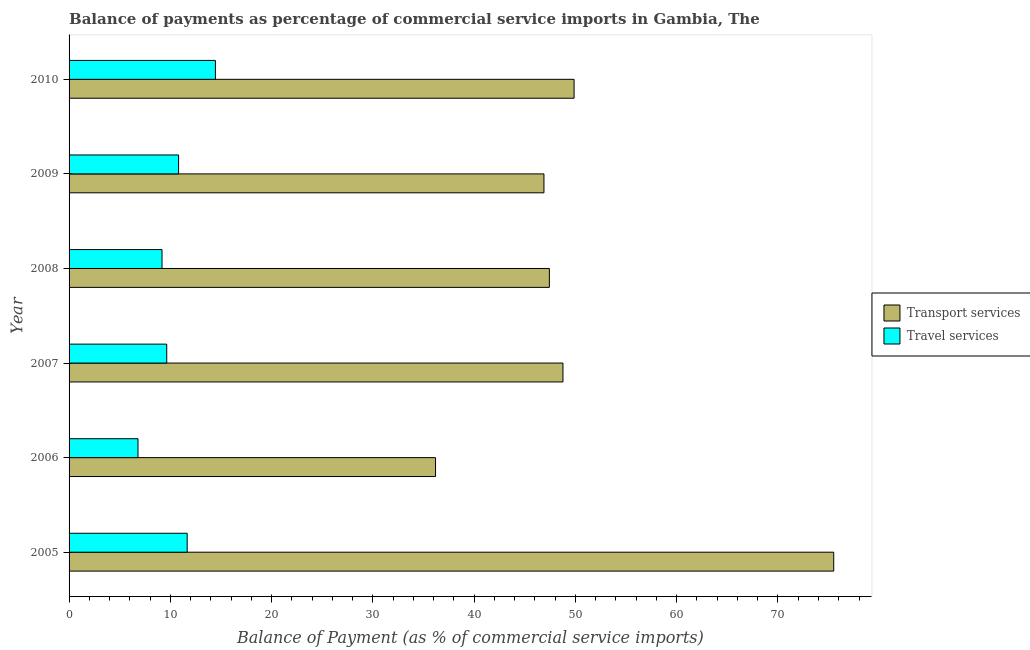How many different coloured bars are there?
Provide a short and direct response. 2. Are the number of bars on each tick of the Y-axis equal?
Keep it short and to the point. Yes. In how many cases, is the number of bars for a given year not equal to the number of legend labels?
Ensure brevity in your answer.  0. What is the balance of payments of travel services in 2005?
Offer a very short reply. 11.66. Across all years, what is the maximum balance of payments of transport services?
Your response must be concise. 75.5. Across all years, what is the minimum balance of payments of travel services?
Your response must be concise. 6.81. In which year was the balance of payments of travel services maximum?
Make the answer very short. 2010. What is the total balance of payments of travel services in the graph?
Your answer should be compact. 62.56. What is the difference between the balance of payments of transport services in 2006 and that in 2009?
Provide a succinct answer. -10.71. What is the difference between the balance of payments of travel services in 2010 and the balance of payments of transport services in 2005?
Your answer should be very brief. -61.05. What is the average balance of payments of travel services per year?
Your answer should be very brief. 10.43. In the year 2010, what is the difference between the balance of payments of transport services and balance of payments of travel services?
Offer a terse response. 35.41. In how many years, is the balance of payments of transport services greater than 54 %?
Provide a short and direct response. 1. What is the ratio of the balance of payments of transport services in 2005 to that in 2006?
Keep it short and to the point. 2.09. What is the difference between the highest and the second highest balance of payments of transport services?
Offer a very short reply. 25.64. What is the difference between the highest and the lowest balance of payments of transport services?
Your answer should be compact. 39.32. In how many years, is the balance of payments of travel services greater than the average balance of payments of travel services taken over all years?
Make the answer very short. 3. What does the 2nd bar from the top in 2008 represents?
Give a very brief answer. Transport services. What does the 1st bar from the bottom in 2007 represents?
Provide a succinct answer. Transport services. How many bars are there?
Provide a short and direct response. 12. Are all the bars in the graph horizontal?
Make the answer very short. Yes. Does the graph contain any zero values?
Your answer should be compact. No. Does the graph contain grids?
Offer a terse response. No. Where does the legend appear in the graph?
Ensure brevity in your answer.  Center right. How many legend labels are there?
Your response must be concise. 2. What is the title of the graph?
Offer a terse response. Balance of payments as percentage of commercial service imports in Gambia, The. What is the label or title of the X-axis?
Provide a short and direct response. Balance of Payment (as % of commercial service imports). What is the label or title of the Y-axis?
Offer a very short reply. Year. What is the Balance of Payment (as % of commercial service imports) in Transport services in 2005?
Your answer should be very brief. 75.5. What is the Balance of Payment (as % of commercial service imports) in Travel services in 2005?
Your response must be concise. 11.66. What is the Balance of Payment (as % of commercial service imports) in Transport services in 2006?
Offer a very short reply. 36.18. What is the Balance of Payment (as % of commercial service imports) in Travel services in 2006?
Provide a succinct answer. 6.81. What is the Balance of Payment (as % of commercial service imports) in Transport services in 2007?
Give a very brief answer. 48.77. What is the Balance of Payment (as % of commercial service imports) in Travel services in 2007?
Make the answer very short. 9.64. What is the Balance of Payment (as % of commercial service imports) of Transport services in 2008?
Your response must be concise. 47.43. What is the Balance of Payment (as % of commercial service imports) of Travel services in 2008?
Offer a terse response. 9.18. What is the Balance of Payment (as % of commercial service imports) of Transport services in 2009?
Make the answer very short. 46.89. What is the Balance of Payment (as % of commercial service imports) in Travel services in 2009?
Provide a short and direct response. 10.81. What is the Balance of Payment (as % of commercial service imports) in Transport services in 2010?
Provide a short and direct response. 49.87. What is the Balance of Payment (as % of commercial service imports) in Travel services in 2010?
Make the answer very short. 14.45. Across all years, what is the maximum Balance of Payment (as % of commercial service imports) in Transport services?
Provide a short and direct response. 75.5. Across all years, what is the maximum Balance of Payment (as % of commercial service imports) in Travel services?
Provide a short and direct response. 14.45. Across all years, what is the minimum Balance of Payment (as % of commercial service imports) of Transport services?
Give a very brief answer. 36.18. Across all years, what is the minimum Balance of Payment (as % of commercial service imports) of Travel services?
Your answer should be very brief. 6.81. What is the total Balance of Payment (as % of commercial service imports) in Transport services in the graph?
Ensure brevity in your answer.  304.64. What is the total Balance of Payment (as % of commercial service imports) of Travel services in the graph?
Keep it short and to the point. 62.55. What is the difference between the Balance of Payment (as % of commercial service imports) in Transport services in 2005 and that in 2006?
Your answer should be very brief. 39.32. What is the difference between the Balance of Payment (as % of commercial service imports) in Travel services in 2005 and that in 2006?
Provide a succinct answer. 4.86. What is the difference between the Balance of Payment (as % of commercial service imports) of Transport services in 2005 and that in 2007?
Make the answer very short. 26.74. What is the difference between the Balance of Payment (as % of commercial service imports) in Travel services in 2005 and that in 2007?
Provide a succinct answer. 2.02. What is the difference between the Balance of Payment (as % of commercial service imports) in Transport services in 2005 and that in 2008?
Ensure brevity in your answer.  28.08. What is the difference between the Balance of Payment (as % of commercial service imports) in Travel services in 2005 and that in 2008?
Provide a short and direct response. 2.49. What is the difference between the Balance of Payment (as % of commercial service imports) of Transport services in 2005 and that in 2009?
Offer a terse response. 28.61. What is the difference between the Balance of Payment (as % of commercial service imports) in Travel services in 2005 and that in 2009?
Provide a succinct answer. 0.85. What is the difference between the Balance of Payment (as % of commercial service imports) of Transport services in 2005 and that in 2010?
Your response must be concise. 25.64. What is the difference between the Balance of Payment (as % of commercial service imports) in Travel services in 2005 and that in 2010?
Give a very brief answer. -2.79. What is the difference between the Balance of Payment (as % of commercial service imports) of Transport services in 2006 and that in 2007?
Your answer should be very brief. -12.58. What is the difference between the Balance of Payment (as % of commercial service imports) in Travel services in 2006 and that in 2007?
Offer a very short reply. -2.84. What is the difference between the Balance of Payment (as % of commercial service imports) of Transport services in 2006 and that in 2008?
Your answer should be very brief. -11.24. What is the difference between the Balance of Payment (as % of commercial service imports) of Travel services in 2006 and that in 2008?
Provide a short and direct response. -2.37. What is the difference between the Balance of Payment (as % of commercial service imports) in Transport services in 2006 and that in 2009?
Provide a short and direct response. -10.71. What is the difference between the Balance of Payment (as % of commercial service imports) in Travel services in 2006 and that in 2009?
Keep it short and to the point. -4.01. What is the difference between the Balance of Payment (as % of commercial service imports) in Transport services in 2006 and that in 2010?
Give a very brief answer. -13.68. What is the difference between the Balance of Payment (as % of commercial service imports) of Travel services in 2006 and that in 2010?
Provide a short and direct response. -7.64. What is the difference between the Balance of Payment (as % of commercial service imports) in Transport services in 2007 and that in 2008?
Your response must be concise. 1.34. What is the difference between the Balance of Payment (as % of commercial service imports) in Travel services in 2007 and that in 2008?
Make the answer very short. 0.47. What is the difference between the Balance of Payment (as % of commercial service imports) of Transport services in 2007 and that in 2009?
Your answer should be very brief. 1.88. What is the difference between the Balance of Payment (as % of commercial service imports) of Travel services in 2007 and that in 2009?
Give a very brief answer. -1.17. What is the difference between the Balance of Payment (as % of commercial service imports) in Transport services in 2007 and that in 2010?
Give a very brief answer. -1.1. What is the difference between the Balance of Payment (as % of commercial service imports) in Travel services in 2007 and that in 2010?
Offer a very short reply. -4.81. What is the difference between the Balance of Payment (as % of commercial service imports) in Transport services in 2008 and that in 2009?
Your response must be concise. 0.54. What is the difference between the Balance of Payment (as % of commercial service imports) in Travel services in 2008 and that in 2009?
Your response must be concise. -1.64. What is the difference between the Balance of Payment (as % of commercial service imports) in Transport services in 2008 and that in 2010?
Offer a terse response. -2.44. What is the difference between the Balance of Payment (as % of commercial service imports) in Travel services in 2008 and that in 2010?
Your response must be concise. -5.27. What is the difference between the Balance of Payment (as % of commercial service imports) of Transport services in 2009 and that in 2010?
Your answer should be compact. -2.98. What is the difference between the Balance of Payment (as % of commercial service imports) in Travel services in 2009 and that in 2010?
Your answer should be compact. -3.64. What is the difference between the Balance of Payment (as % of commercial service imports) of Transport services in 2005 and the Balance of Payment (as % of commercial service imports) of Travel services in 2006?
Keep it short and to the point. 68.7. What is the difference between the Balance of Payment (as % of commercial service imports) of Transport services in 2005 and the Balance of Payment (as % of commercial service imports) of Travel services in 2007?
Offer a very short reply. 65.86. What is the difference between the Balance of Payment (as % of commercial service imports) in Transport services in 2005 and the Balance of Payment (as % of commercial service imports) in Travel services in 2008?
Keep it short and to the point. 66.32. What is the difference between the Balance of Payment (as % of commercial service imports) of Transport services in 2005 and the Balance of Payment (as % of commercial service imports) of Travel services in 2009?
Your response must be concise. 64.69. What is the difference between the Balance of Payment (as % of commercial service imports) of Transport services in 2005 and the Balance of Payment (as % of commercial service imports) of Travel services in 2010?
Give a very brief answer. 61.05. What is the difference between the Balance of Payment (as % of commercial service imports) of Transport services in 2006 and the Balance of Payment (as % of commercial service imports) of Travel services in 2007?
Offer a very short reply. 26.54. What is the difference between the Balance of Payment (as % of commercial service imports) in Transport services in 2006 and the Balance of Payment (as % of commercial service imports) in Travel services in 2008?
Your answer should be very brief. 27.01. What is the difference between the Balance of Payment (as % of commercial service imports) of Transport services in 2006 and the Balance of Payment (as % of commercial service imports) of Travel services in 2009?
Provide a succinct answer. 25.37. What is the difference between the Balance of Payment (as % of commercial service imports) of Transport services in 2006 and the Balance of Payment (as % of commercial service imports) of Travel services in 2010?
Your response must be concise. 21.73. What is the difference between the Balance of Payment (as % of commercial service imports) of Transport services in 2007 and the Balance of Payment (as % of commercial service imports) of Travel services in 2008?
Your answer should be very brief. 39.59. What is the difference between the Balance of Payment (as % of commercial service imports) in Transport services in 2007 and the Balance of Payment (as % of commercial service imports) in Travel services in 2009?
Provide a short and direct response. 37.95. What is the difference between the Balance of Payment (as % of commercial service imports) of Transport services in 2007 and the Balance of Payment (as % of commercial service imports) of Travel services in 2010?
Give a very brief answer. 34.32. What is the difference between the Balance of Payment (as % of commercial service imports) in Transport services in 2008 and the Balance of Payment (as % of commercial service imports) in Travel services in 2009?
Offer a terse response. 36.61. What is the difference between the Balance of Payment (as % of commercial service imports) in Transport services in 2008 and the Balance of Payment (as % of commercial service imports) in Travel services in 2010?
Provide a short and direct response. 32.97. What is the difference between the Balance of Payment (as % of commercial service imports) in Transport services in 2009 and the Balance of Payment (as % of commercial service imports) in Travel services in 2010?
Offer a terse response. 32.44. What is the average Balance of Payment (as % of commercial service imports) in Transport services per year?
Offer a terse response. 50.77. What is the average Balance of Payment (as % of commercial service imports) in Travel services per year?
Provide a succinct answer. 10.43. In the year 2005, what is the difference between the Balance of Payment (as % of commercial service imports) of Transport services and Balance of Payment (as % of commercial service imports) of Travel services?
Make the answer very short. 63.84. In the year 2006, what is the difference between the Balance of Payment (as % of commercial service imports) in Transport services and Balance of Payment (as % of commercial service imports) in Travel services?
Make the answer very short. 29.38. In the year 2007, what is the difference between the Balance of Payment (as % of commercial service imports) of Transport services and Balance of Payment (as % of commercial service imports) of Travel services?
Provide a succinct answer. 39.12. In the year 2008, what is the difference between the Balance of Payment (as % of commercial service imports) of Transport services and Balance of Payment (as % of commercial service imports) of Travel services?
Your answer should be compact. 38.25. In the year 2009, what is the difference between the Balance of Payment (as % of commercial service imports) of Transport services and Balance of Payment (as % of commercial service imports) of Travel services?
Your answer should be very brief. 36.08. In the year 2010, what is the difference between the Balance of Payment (as % of commercial service imports) in Transport services and Balance of Payment (as % of commercial service imports) in Travel services?
Provide a succinct answer. 35.41. What is the ratio of the Balance of Payment (as % of commercial service imports) in Transport services in 2005 to that in 2006?
Your answer should be compact. 2.09. What is the ratio of the Balance of Payment (as % of commercial service imports) in Travel services in 2005 to that in 2006?
Make the answer very short. 1.71. What is the ratio of the Balance of Payment (as % of commercial service imports) in Transport services in 2005 to that in 2007?
Provide a short and direct response. 1.55. What is the ratio of the Balance of Payment (as % of commercial service imports) of Travel services in 2005 to that in 2007?
Give a very brief answer. 1.21. What is the ratio of the Balance of Payment (as % of commercial service imports) in Transport services in 2005 to that in 2008?
Your answer should be very brief. 1.59. What is the ratio of the Balance of Payment (as % of commercial service imports) of Travel services in 2005 to that in 2008?
Your response must be concise. 1.27. What is the ratio of the Balance of Payment (as % of commercial service imports) in Transport services in 2005 to that in 2009?
Your answer should be very brief. 1.61. What is the ratio of the Balance of Payment (as % of commercial service imports) of Travel services in 2005 to that in 2009?
Your answer should be compact. 1.08. What is the ratio of the Balance of Payment (as % of commercial service imports) in Transport services in 2005 to that in 2010?
Provide a short and direct response. 1.51. What is the ratio of the Balance of Payment (as % of commercial service imports) in Travel services in 2005 to that in 2010?
Provide a short and direct response. 0.81. What is the ratio of the Balance of Payment (as % of commercial service imports) in Transport services in 2006 to that in 2007?
Provide a short and direct response. 0.74. What is the ratio of the Balance of Payment (as % of commercial service imports) of Travel services in 2006 to that in 2007?
Make the answer very short. 0.71. What is the ratio of the Balance of Payment (as % of commercial service imports) of Transport services in 2006 to that in 2008?
Provide a succinct answer. 0.76. What is the ratio of the Balance of Payment (as % of commercial service imports) of Travel services in 2006 to that in 2008?
Provide a short and direct response. 0.74. What is the ratio of the Balance of Payment (as % of commercial service imports) in Transport services in 2006 to that in 2009?
Give a very brief answer. 0.77. What is the ratio of the Balance of Payment (as % of commercial service imports) in Travel services in 2006 to that in 2009?
Your answer should be compact. 0.63. What is the ratio of the Balance of Payment (as % of commercial service imports) in Transport services in 2006 to that in 2010?
Offer a terse response. 0.73. What is the ratio of the Balance of Payment (as % of commercial service imports) in Travel services in 2006 to that in 2010?
Your answer should be compact. 0.47. What is the ratio of the Balance of Payment (as % of commercial service imports) of Transport services in 2007 to that in 2008?
Make the answer very short. 1.03. What is the ratio of the Balance of Payment (as % of commercial service imports) in Travel services in 2007 to that in 2008?
Offer a very short reply. 1.05. What is the ratio of the Balance of Payment (as % of commercial service imports) in Transport services in 2007 to that in 2009?
Give a very brief answer. 1.04. What is the ratio of the Balance of Payment (as % of commercial service imports) in Travel services in 2007 to that in 2009?
Provide a short and direct response. 0.89. What is the ratio of the Balance of Payment (as % of commercial service imports) of Travel services in 2007 to that in 2010?
Your answer should be compact. 0.67. What is the ratio of the Balance of Payment (as % of commercial service imports) in Transport services in 2008 to that in 2009?
Your answer should be very brief. 1.01. What is the ratio of the Balance of Payment (as % of commercial service imports) in Travel services in 2008 to that in 2009?
Your response must be concise. 0.85. What is the ratio of the Balance of Payment (as % of commercial service imports) of Transport services in 2008 to that in 2010?
Offer a very short reply. 0.95. What is the ratio of the Balance of Payment (as % of commercial service imports) of Travel services in 2008 to that in 2010?
Your response must be concise. 0.64. What is the ratio of the Balance of Payment (as % of commercial service imports) in Transport services in 2009 to that in 2010?
Provide a short and direct response. 0.94. What is the ratio of the Balance of Payment (as % of commercial service imports) in Travel services in 2009 to that in 2010?
Provide a short and direct response. 0.75. What is the difference between the highest and the second highest Balance of Payment (as % of commercial service imports) of Transport services?
Your response must be concise. 25.64. What is the difference between the highest and the second highest Balance of Payment (as % of commercial service imports) in Travel services?
Offer a very short reply. 2.79. What is the difference between the highest and the lowest Balance of Payment (as % of commercial service imports) of Transport services?
Make the answer very short. 39.32. What is the difference between the highest and the lowest Balance of Payment (as % of commercial service imports) in Travel services?
Ensure brevity in your answer.  7.64. 